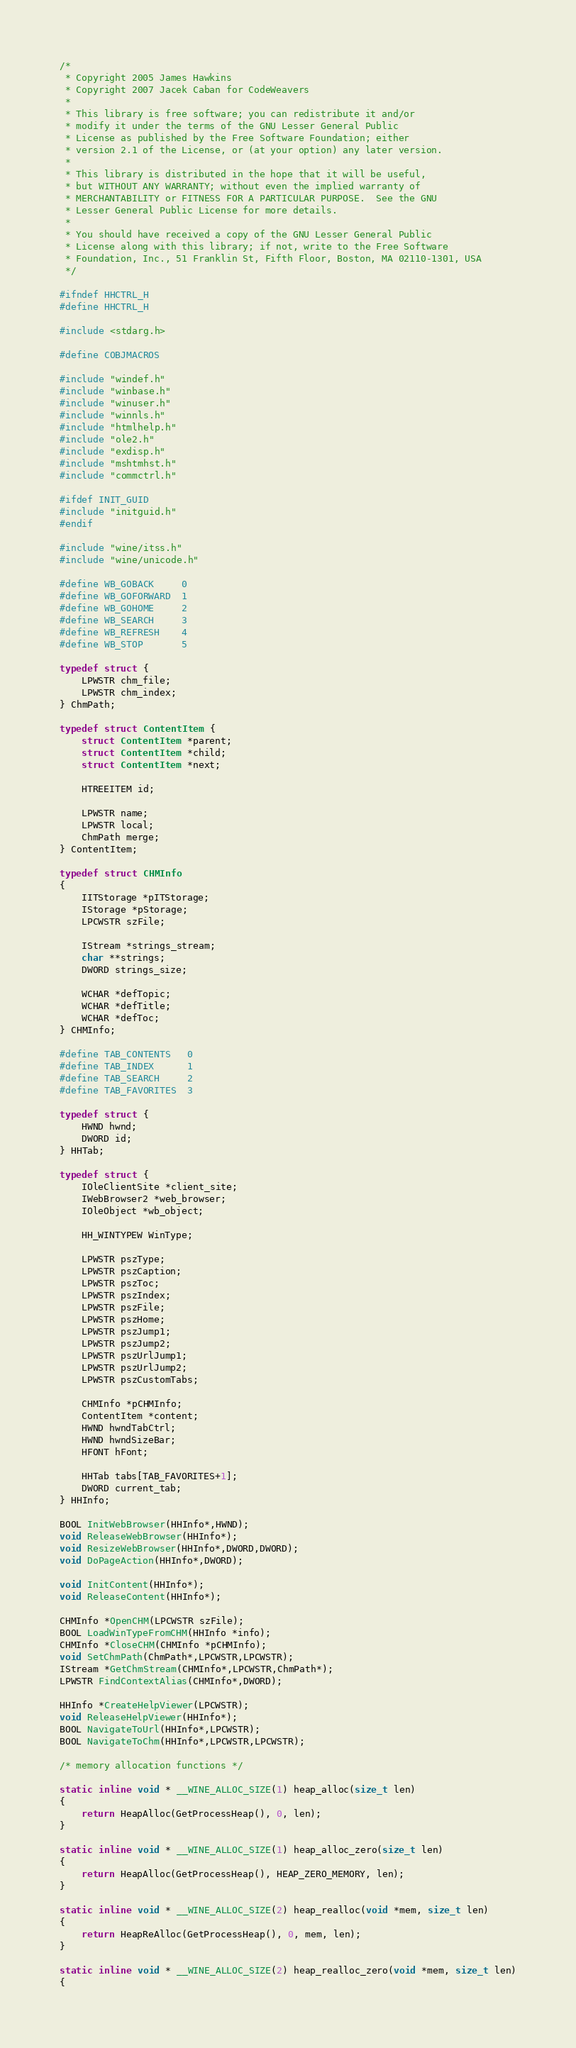<code> <loc_0><loc_0><loc_500><loc_500><_C_>/*
 * Copyright 2005 James Hawkins
 * Copyright 2007 Jacek Caban for CodeWeavers
 *
 * This library is free software; you can redistribute it and/or
 * modify it under the terms of the GNU Lesser General Public
 * License as published by the Free Software Foundation; either
 * version 2.1 of the License, or (at your option) any later version.
 *
 * This library is distributed in the hope that it will be useful,
 * but WITHOUT ANY WARRANTY; without even the implied warranty of
 * MERCHANTABILITY or FITNESS FOR A PARTICULAR PURPOSE.  See the GNU
 * Lesser General Public License for more details.
 *
 * You should have received a copy of the GNU Lesser General Public
 * License along with this library; if not, write to the Free Software
 * Foundation, Inc., 51 Franklin St, Fifth Floor, Boston, MA 02110-1301, USA
 */

#ifndef HHCTRL_H
#define HHCTRL_H

#include <stdarg.h>

#define COBJMACROS

#include "windef.h"
#include "winbase.h"
#include "winuser.h"
#include "winnls.h"
#include "htmlhelp.h"
#include "ole2.h"
#include "exdisp.h"
#include "mshtmhst.h"
#include "commctrl.h"

#ifdef INIT_GUID
#include "initguid.h"
#endif

#include "wine/itss.h"
#include "wine/unicode.h"

#define WB_GOBACK     0
#define WB_GOFORWARD  1
#define WB_GOHOME     2
#define WB_SEARCH     3
#define WB_REFRESH    4
#define WB_STOP       5

typedef struct {
    LPWSTR chm_file;
    LPWSTR chm_index;
} ChmPath;

typedef struct ContentItem {
    struct ContentItem *parent;
    struct ContentItem *child;
    struct ContentItem *next;

    HTREEITEM id;

    LPWSTR name;
    LPWSTR local;
    ChmPath merge;
} ContentItem;

typedef struct CHMInfo
{
    IITStorage *pITStorage;
    IStorage *pStorage;
    LPCWSTR szFile;

    IStream *strings_stream;
    char **strings;
    DWORD strings_size;

    WCHAR *defTopic;
    WCHAR *defTitle;
    WCHAR *defToc;
} CHMInfo;

#define TAB_CONTENTS   0
#define TAB_INDEX      1
#define TAB_SEARCH     2
#define TAB_FAVORITES  3

typedef struct {
    HWND hwnd;
    DWORD id;
} HHTab;

typedef struct {
    IOleClientSite *client_site;
    IWebBrowser2 *web_browser;
    IOleObject *wb_object;

    HH_WINTYPEW WinType;

    LPWSTR pszType;
    LPWSTR pszCaption;
    LPWSTR pszToc;
    LPWSTR pszIndex;
    LPWSTR pszFile;
    LPWSTR pszHome;
    LPWSTR pszJump1;
    LPWSTR pszJump2;
    LPWSTR pszUrlJump1;
    LPWSTR pszUrlJump2;
    LPWSTR pszCustomTabs;

    CHMInfo *pCHMInfo;
    ContentItem *content;
    HWND hwndTabCtrl;
    HWND hwndSizeBar;
    HFONT hFont;

    HHTab tabs[TAB_FAVORITES+1];
    DWORD current_tab;
} HHInfo;

BOOL InitWebBrowser(HHInfo*,HWND);
void ReleaseWebBrowser(HHInfo*);
void ResizeWebBrowser(HHInfo*,DWORD,DWORD);
void DoPageAction(HHInfo*,DWORD);

void InitContent(HHInfo*);
void ReleaseContent(HHInfo*);

CHMInfo *OpenCHM(LPCWSTR szFile);
BOOL LoadWinTypeFromCHM(HHInfo *info);
CHMInfo *CloseCHM(CHMInfo *pCHMInfo);
void SetChmPath(ChmPath*,LPCWSTR,LPCWSTR);
IStream *GetChmStream(CHMInfo*,LPCWSTR,ChmPath*);
LPWSTR FindContextAlias(CHMInfo*,DWORD);

HHInfo *CreateHelpViewer(LPCWSTR);
void ReleaseHelpViewer(HHInfo*);
BOOL NavigateToUrl(HHInfo*,LPCWSTR);
BOOL NavigateToChm(HHInfo*,LPCWSTR,LPCWSTR);

/* memory allocation functions */

static inline void * __WINE_ALLOC_SIZE(1) heap_alloc(size_t len)
{
    return HeapAlloc(GetProcessHeap(), 0, len);
}

static inline void * __WINE_ALLOC_SIZE(1) heap_alloc_zero(size_t len)
{
    return HeapAlloc(GetProcessHeap(), HEAP_ZERO_MEMORY, len);
}

static inline void * __WINE_ALLOC_SIZE(2) heap_realloc(void *mem, size_t len)
{
    return HeapReAlloc(GetProcessHeap(), 0, mem, len);
}

static inline void * __WINE_ALLOC_SIZE(2) heap_realloc_zero(void *mem, size_t len)
{</code> 